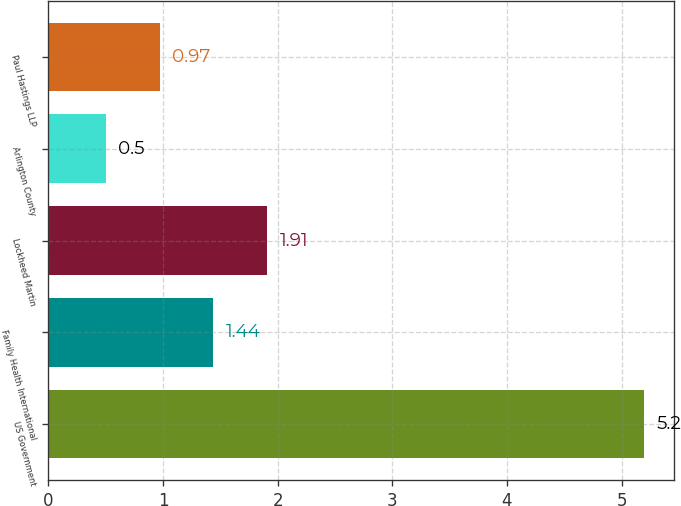<chart> <loc_0><loc_0><loc_500><loc_500><bar_chart><fcel>US Government<fcel>Family Health International<fcel>Lockheed Martin<fcel>Arlington County<fcel>Paul Hastings LLP<nl><fcel>5.2<fcel>1.44<fcel>1.91<fcel>0.5<fcel>0.97<nl></chart> 